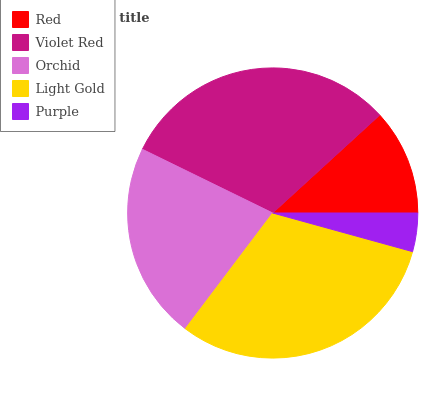Is Purple the minimum?
Answer yes or no. Yes. Is Light Gold the maximum?
Answer yes or no. Yes. Is Violet Red the minimum?
Answer yes or no. No. Is Violet Red the maximum?
Answer yes or no. No. Is Violet Red greater than Red?
Answer yes or no. Yes. Is Red less than Violet Red?
Answer yes or no. Yes. Is Red greater than Violet Red?
Answer yes or no. No. Is Violet Red less than Red?
Answer yes or no. No. Is Orchid the high median?
Answer yes or no. Yes. Is Orchid the low median?
Answer yes or no. Yes. Is Red the high median?
Answer yes or no. No. Is Light Gold the low median?
Answer yes or no. No. 